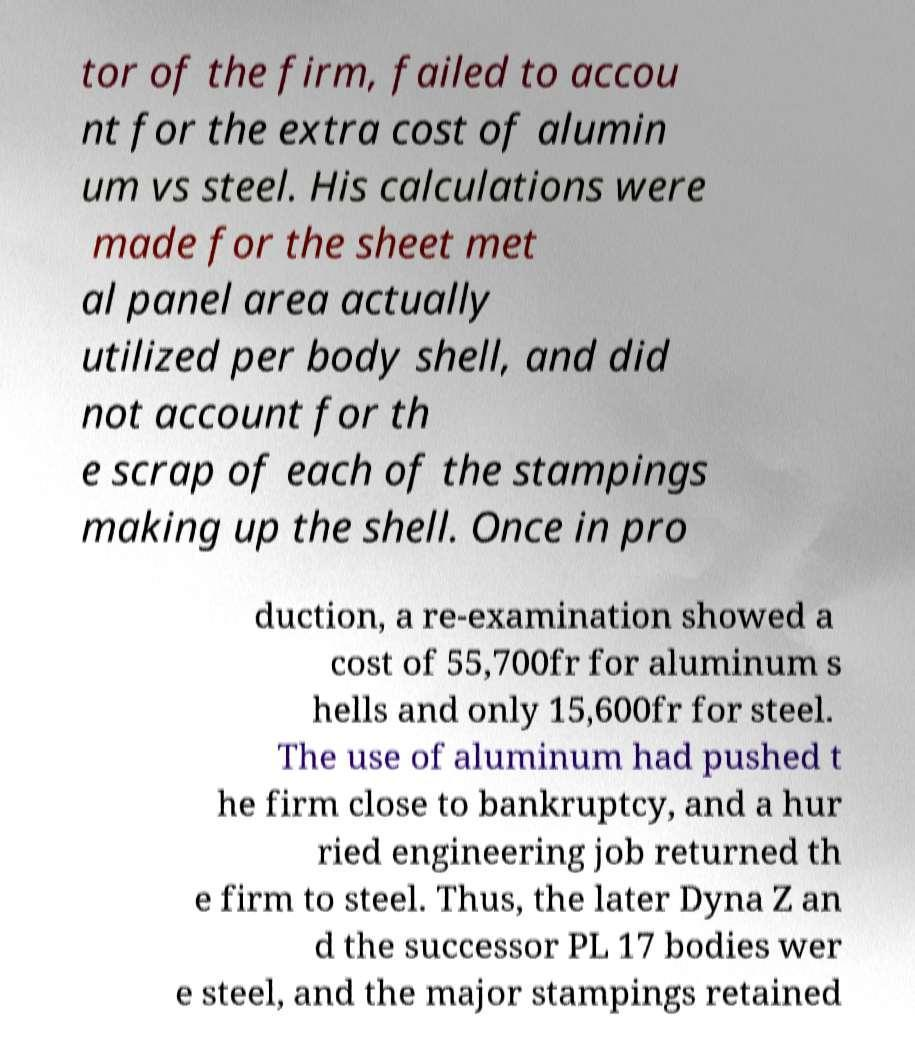What messages or text are displayed in this image? I need them in a readable, typed format. tor of the firm, failed to accou nt for the extra cost of alumin um vs steel. His calculations were made for the sheet met al panel area actually utilized per body shell, and did not account for th e scrap of each of the stampings making up the shell. Once in pro duction, a re-examination showed a cost of 55,700fr for aluminum s hells and only 15,600fr for steel. The use of aluminum had pushed t he firm close to bankruptcy, and a hur ried engineering job returned th e firm to steel. Thus, the later Dyna Z an d the successor PL 17 bodies wer e steel, and the major stampings retained 